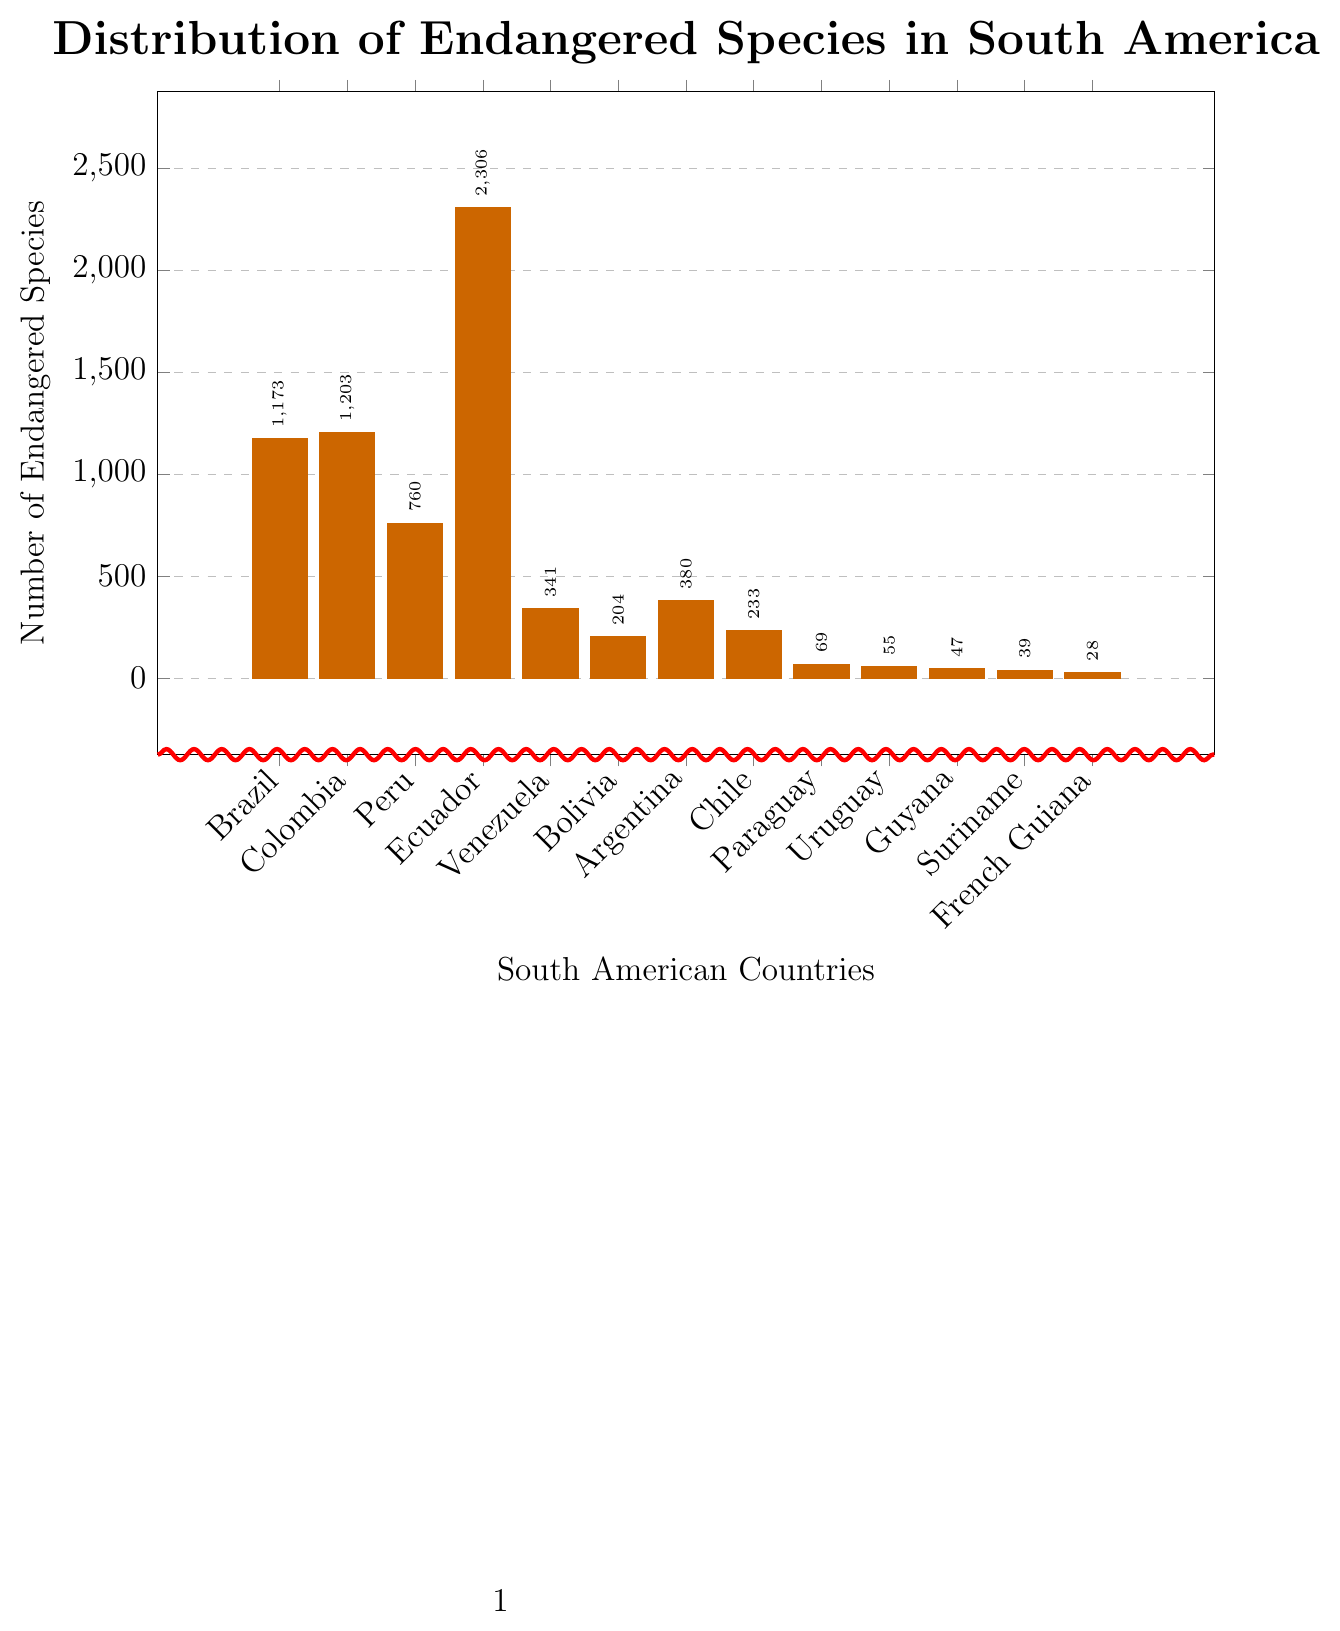Which country has the highest number of endangered species? Looking at the tallest bar in the chart, which corresponds to Ecuador, we see that it has the highest value at 2306.
Answer: Ecuador Which country has the lowest number of endangered species? The shortest bar in the chart represents French Guiana, which has only 28 endangered species.
Answer: French Guiana How many more endangered species does Ecuador have compared to Brazil? Ecuador has a bar of 2306 endangered species while Brazil has 1173. Subtracting these values gives 2306 - 1173 = 1133 more species in Ecuador.
Answer: 1133 What is the total number of endangered species in Colombia and Peru combined? The bar for Colombia shows 1203 and the bar for Peru shows 760. Adding these together gives 1203 + 760 = 1963 endangered species.
Answer: 1963 Which countries have fewer than 100 endangered species? By looking at the height of the bars, we see that Paraguay (69), Uruguay (55), Guyana (47), Suriname (39), and French Guiana (28) each have fewer than 100 species.
Answer: Paraguay, Uruguay, Guyana, Suriname, French Guiana Is the number of endangered species in Argentina greater than in Venezuela? Comparing the bars for Argentina (380) and Venezuela (341), we see that Argentina has a greater number of endangered species.
Answer: Yes How many more endangered species are there in Ecuador than in Chile? Ecuador has 2306 endangered species, and Chile has 233. Subtracting these values gives 2306 - 233 = 2073 more species in Ecuador.
Answer: 2073 What is the average number of endangered species across all the listed countries? Summing all the values: 1173 + 1203 + 760 + 2306 + 341 + 204 + 380 + 233 + 69 + 55 + 47 + 39 + 28 = 6838. There are 13 countries, so dividing the total by 13 gives 6838 / 13 ≈ 526.
Answer: 526 Which two neighboring countries (next to each other when ordered in the chart) have the most significant difference in the number of endangered species? By examining the differences between consecutive bars, the biggest difference is between Ecuador (2306) and Peru (760), giving 2306 - 760 = 1546.
Answer: Ecuador and Peru 